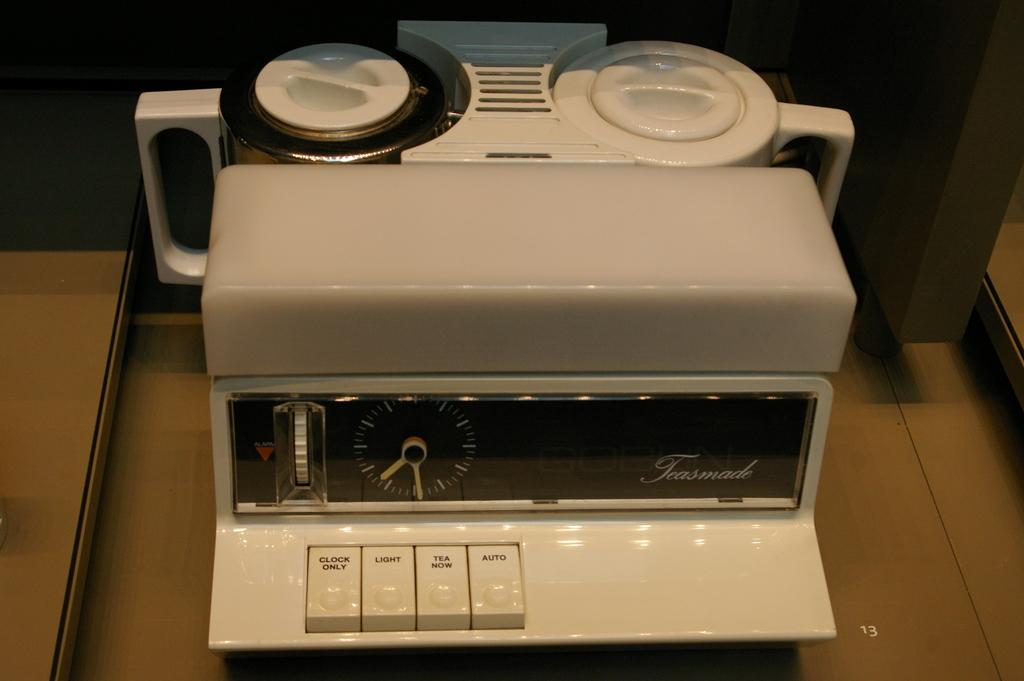<image>
Create a compact narrative representing the image presented. an old fashioned percolator with clock from Teasmade 